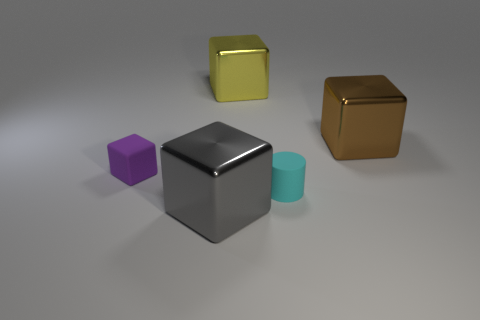Subtract all large brown shiny cubes. How many cubes are left? 3 Add 4 red cylinders. How many objects exist? 9 Subtract 4 blocks. How many blocks are left? 0 Subtract all brown cubes. How many cubes are left? 3 Subtract 0 purple balls. How many objects are left? 5 Subtract all blocks. How many objects are left? 1 Subtract all green cylinders. Subtract all cyan cubes. How many cylinders are left? 1 Subtract all yellow cylinders. How many gray blocks are left? 1 Subtract all tiny cylinders. Subtract all small matte cylinders. How many objects are left? 3 Add 3 large metallic cubes. How many large metallic cubes are left? 6 